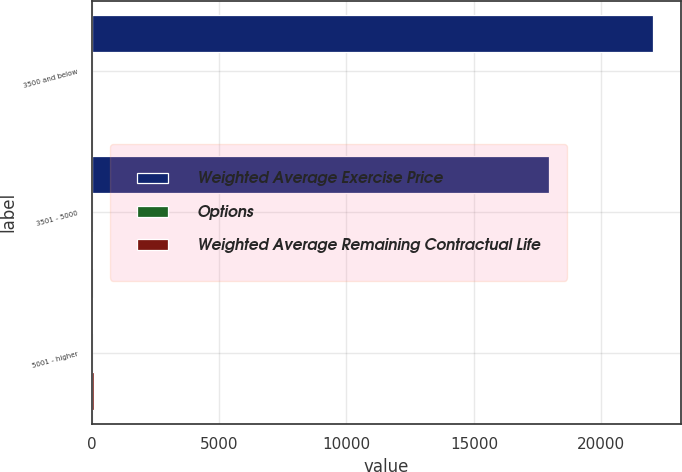Convert chart to OTSL. <chart><loc_0><loc_0><loc_500><loc_500><stacked_bar_chart><ecel><fcel>3500 and below<fcel>3501 - 5000<fcel>5001 - higher<nl><fcel>Weighted Average Exercise Price<fcel>22040<fcel>17956<fcel>40.04<nl><fcel>Options<fcel>0.97<fcel>1.08<fcel>6.67<nl><fcel>Weighted Average Remaining Contractual Life<fcel>33.11<fcel>46.97<fcel>102.95<nl></chart> 